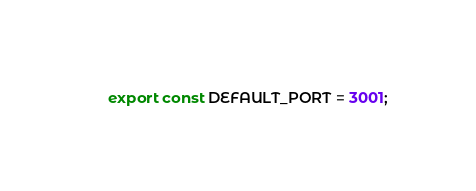<code> <loc_0><loc_0><loc_500><loc_500><_TypeScript_>export const DEFAULT_PORT = 3001;
</code> 